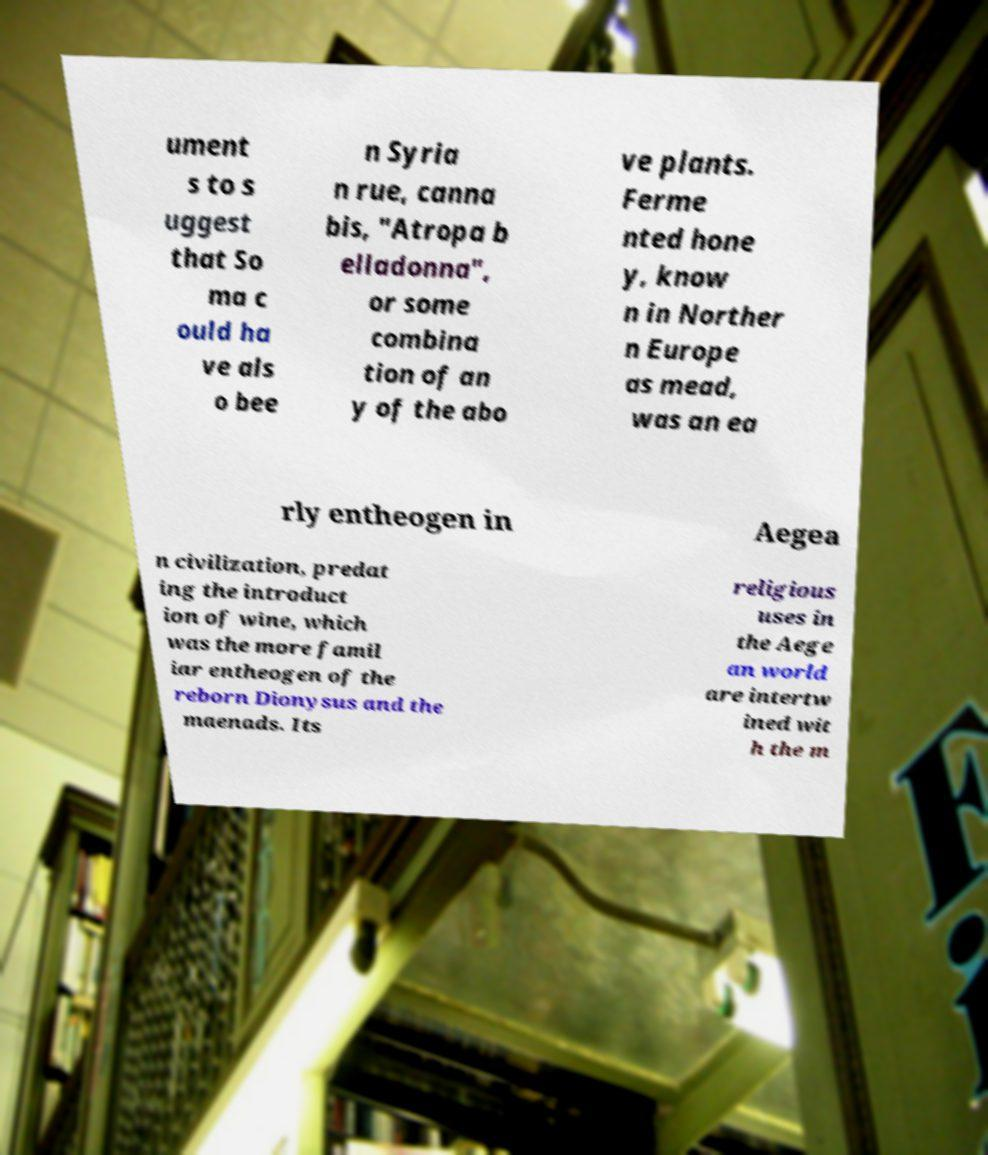Could you assist in decoding the text presented in this image and type it out clearly? ument s to s uggest that So ma c ould ha ve als o bee n Syria n rue, canna bis, "Atropa b elladonna", or some combina tion of an y of the abo ve plants. Ferme nted hone y, know n in Norther n Europe as mead, was an ea rly entheogen in Aegea n civilization, predat ing the introduct ion of wine, which was the more famil iar entheogen of the reborn Dionysus and the maenads. Its religious uses in the Aege an world are intertw ined wit h the m 